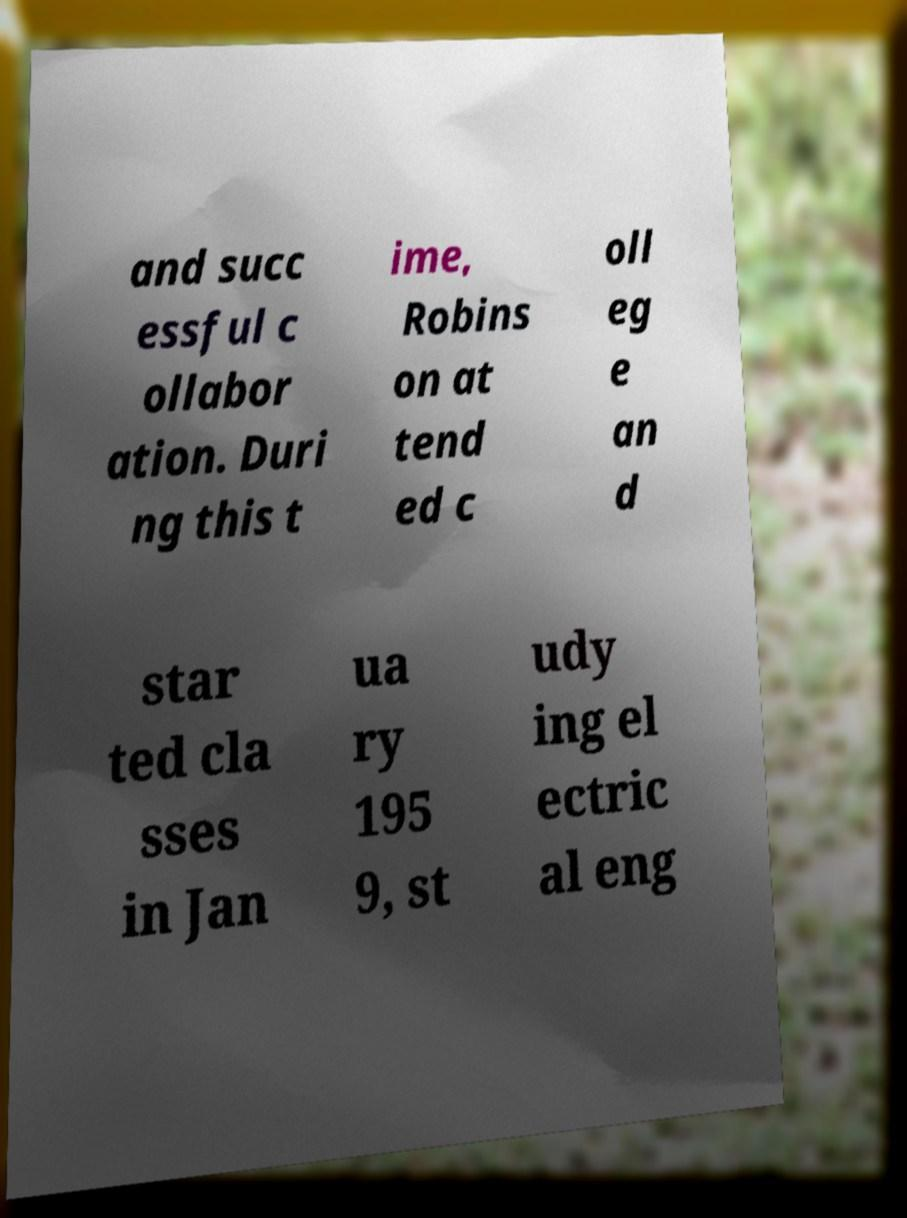Please identify and transcribe the text found in this image. and succ essful c ollabor ation. Duri ng this t ime, Robins on at tend ed c oll eg e an d star ted cla sses in Jan ua ry 195 9, st udy ing el ectric al eng 